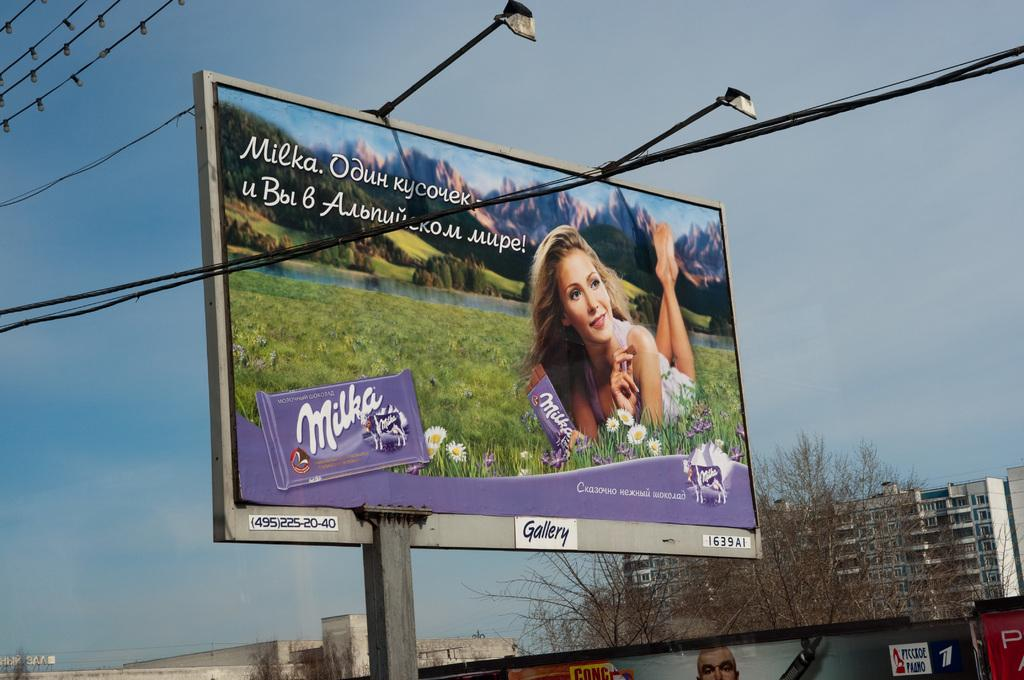<image>
Offer a succinct explanation of the picture presented. A billboard with a woman laying on a field promoting Milka chocolate. 